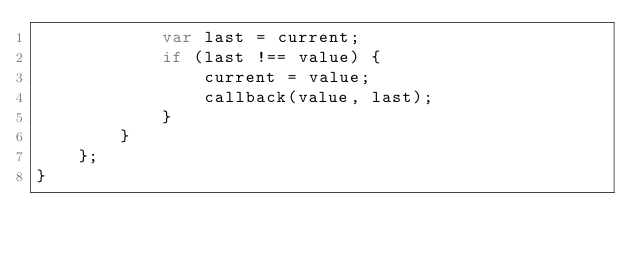<code> <loc_0><loc_0><loc_500><loc_500><_JavaScript_>            var last = current;
            if (last !== value) {
                current = value;
                callback(value, last);
            }
        }
    };
}
</code> 